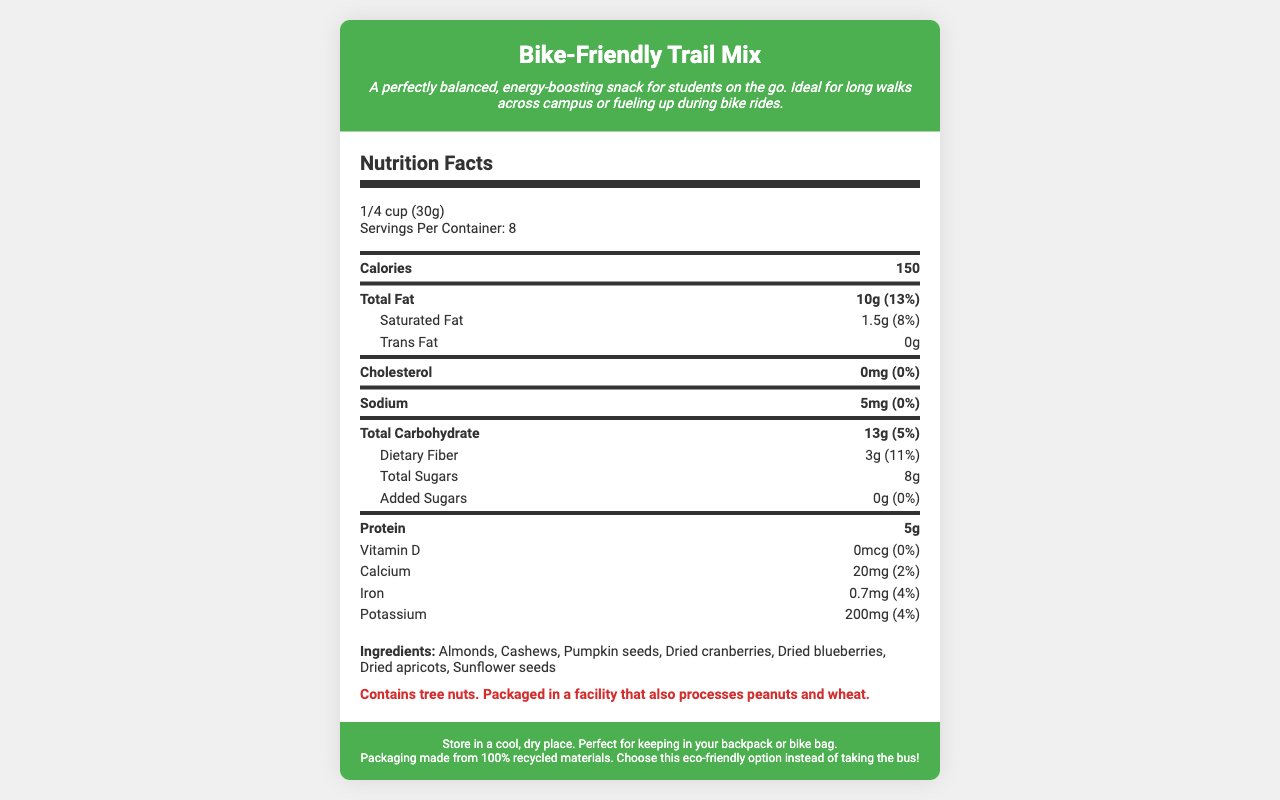who should avoid consuming this trail mix? The document states that the trail mix contains tree nuts and is packaged in a facility that also processes peanuts and wheat.
Answer: People with tree nut allergies how many servings are in one container? The document lists "Servings Per Container: 8" in the serving information section.
Answer: 8 what is the serving size of this trail mix? The document states "servingSize": "1/4 cup (30g)".
Answer: 1/4 cup (30g) how many calories does one serving contain? The document specifies that one serving contains 150 calories.
Answer: 150 calories what is the total fat content in one serving? The document details that each serving has 10g of total fat.
Answer: 10g how much protein is in one serving? The nutrition facts list shows that one serving contains 5g of protein.
Answer: 5g what are the main ingredients in this trail mix? The ingredients listed in the document include these items.
Answer: Almonds, Cashews, Pumpkin seeds, Dried cranberries, Dried blueberries, Dried apricots, Sunflower seeds how much dietary fiber does one serving provide? The nutrition facts indicate that one serving contains 3g of dietary fiber.
Answer: 3g does this trail mix contain any added sugars? The document specifies that there are 0g of added sugars.
Answer: No what percentage of daily value for calcium does one serving of this trail mix provide? The document states that one serving provides 20mg of calcium, which is 2% of the daily value.
Answer: 2% how much iron is in one serving of this trail mix? A. 0.4mg B. 0.7mg C. 1mg D. 1.5mg The document states that each serving contains 0.7mg of iron.
Answer: B which nutrient has the highest daily value percentage per serving in this trail mix? A. Total Fat B. Dietary Fiber C. Potassium D. Saturated Fat Total fat has a daily value of 13%, which is higher than the other nutrients listed.
Answer: A is this trail mix suitable for vegan diets? The document does not provide enough information about whether the ingredients and processing practices are entirely vegan.
Answer: Cannot be determined summarize the key features of this trail mix product. The document highlights the purpose of the product (energy-boosting snack for students), key nutritional components, packaging sustainability, and storage instructions.
Answer: The Bike-Friendly Trail Mix is a balanced, portable snack designed for students on the go. It offers a good mix of nuts, dried fruits, and seeds, providing essential nutrients like protein, dietary fiber, and healthy fats. The nut mix is packaged in recycled materials and includes instructions for safe storage. 